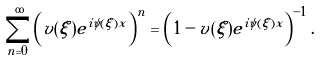Convert formula to latex. <formula><loc_0><loc_0><loc_500><loc_500>\sum _ { n = 0 } ^ { \infty } \left ( v ( \xi ) e ^ { i \psi ( \xi ) x } \right ) ^ { n } = \left ( 1 - v ( \xi ) e ^ { i \psi ( \xi ) x } \right ) ^ { - 1 } .</formula> 